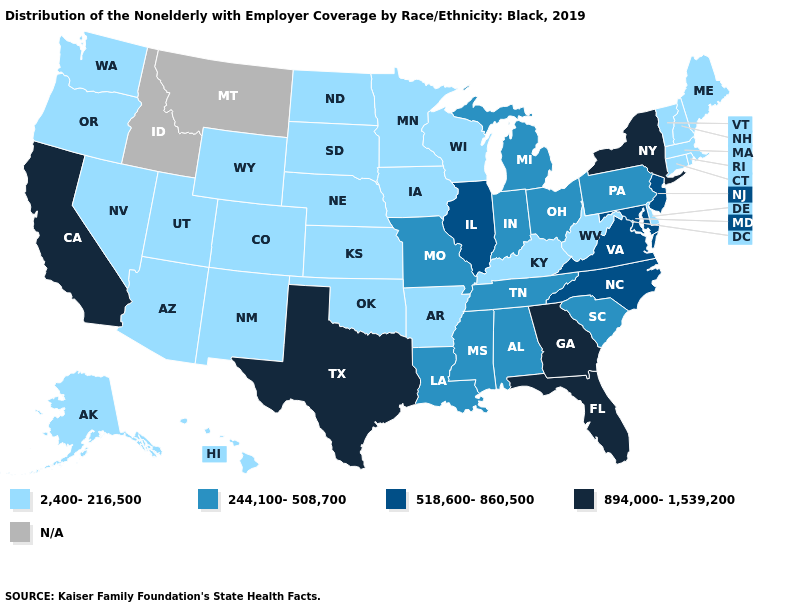Name the states that have a value in the range 894,000-1,539,200?
Keep it brief. California, Florida, Georgia, New York, Texas. Among the states that border Oregon , does California have the lowest value?
Quick response, please. No. Does the map have missing data?
Answer briefly. Yes. Name the states that have a value in the range 2,400-216,500?
Short answer required. Alaska, Arizona, Arkansas, Colorado, Connecticut, Delaware, Hawaii, Iowa, Kansas, Kentucky, Maine, Massachusetts, Minnesota, Nebraska, Nevada, New Hampshire, New Mexico, North Dakota, Oklahoma, Oregon, Rhode Island, South Dakota, Utah, Vermont, Washington, West Virginia, Wisconsin, Wyoming. Does the first symbol in the legend represent the smallest category?
Be succinct. Yes. What is the value of New Hampshire?
Concise answer only. 2,400-216,500. Name the states that have a value in the range 244,100-508,700?
Keep it brief. Alabama, Indiana, Louisiana, Michigan, Mississippi, Missouri, Ohio, Pennsylvania, South Carolina, Tennessee. What is the highest value in states that border South Carolina?
Quick response, please. 894,000-1,539,200. Among the states that border Wisconsin , which have the highest value?
Short answer required. Illinois. Name the states that have a value in the range 518,600-860,500?
Give a very brief answer. Illinois, Maryland, New Jersey, North Carolina, Virginia. What is the value of Colorado?
Be succinct. 2,400-216,500. What is the lowest value in the West?
Concise answer only. 2,400-216,500. What is the value of Massachusetts?
Keep it brief. 2,400-216,500. What is the highest value in the Northeast ?
Keep it brief. 894,000-1,539,200. 